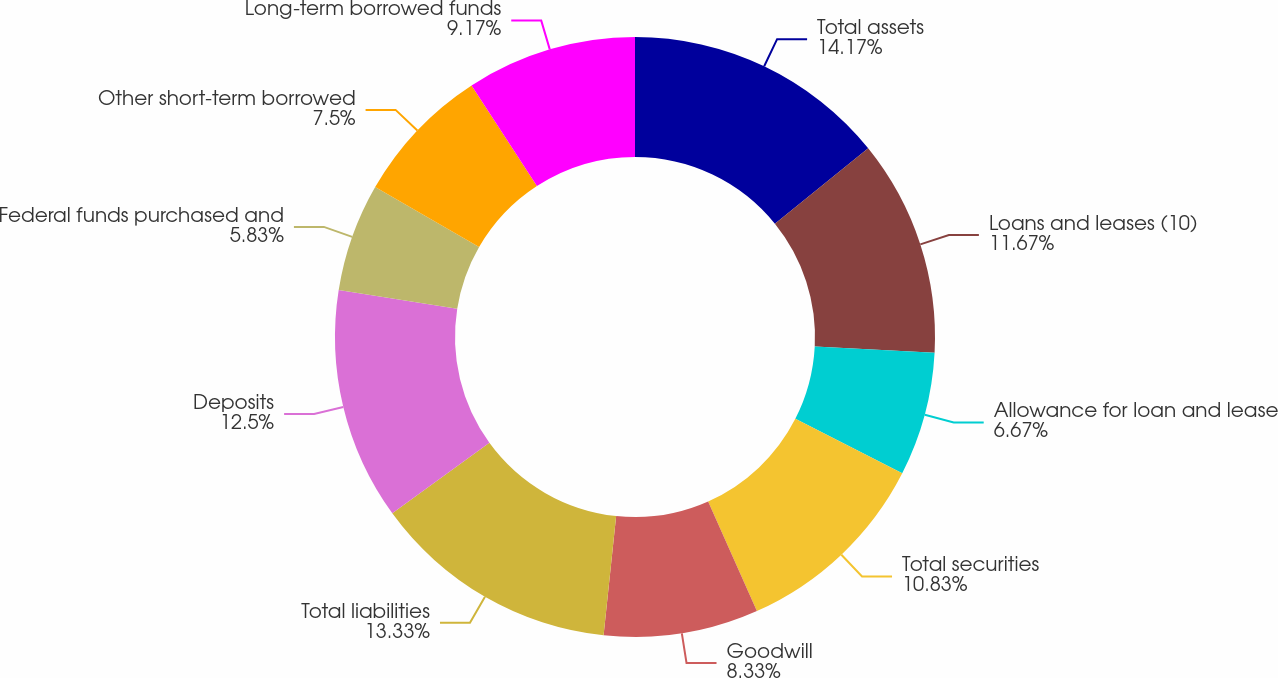Convert chart. <chart><loc_0><loc_0><loc_500><loc_500><pie_chart><fcel>Total assets<fcel>Loans and leases (10)<fcel>Allowance for loan and lease<fcel>Total securities<fcel>Goodwill<fcel>Total liabilities<fcel>Deposits<fcel>Federal funds purchased and<fcel>Other short-term borrowed<fcel>Long-term borrowed funds<nl><fcel>14.17%<fcel>11.67%<fcel>6.67%<fcel>10.83%<fcel>8.33%<fcel>13.33%<fcel>12.5%<fcel>5.83%<fcel>7.5%<fcel>9.17%<nl></chart> 